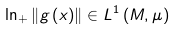Convert formula to latex. <formula><loc_0><loc_0><loc_500><loc_500>\ln _ { + } \left \| g \left ( x \right ) \right \| \in L ^ { 1 } \left ( M , \mu \right )</formula> 